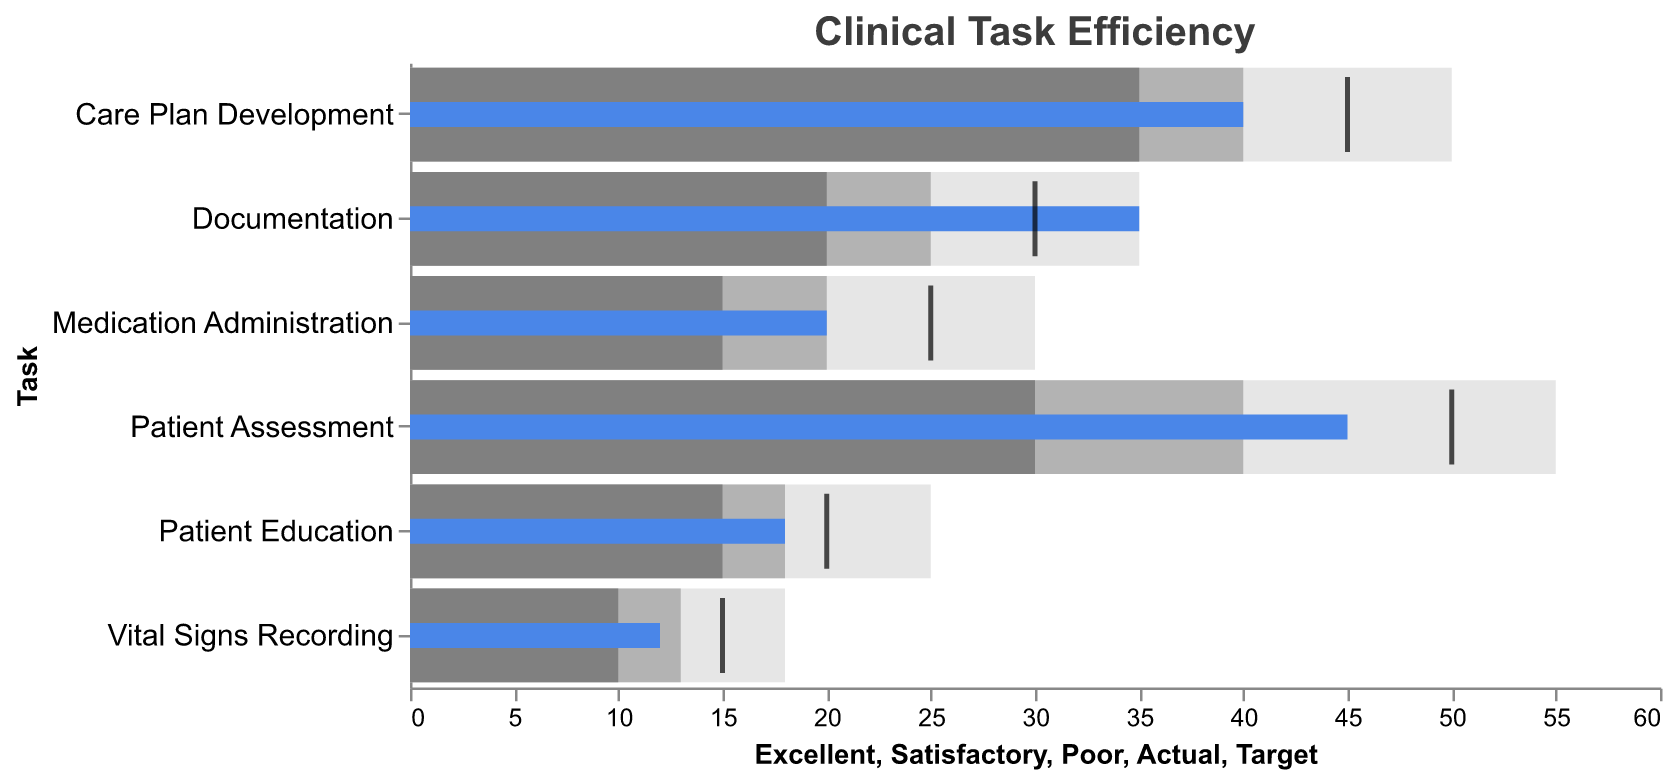What is the title of the chart? The title is displayed prominently at the top of the chart. It reads "Clinical Task Efficiency," indicating that the chart is about how efficiently clinical tasks are managed.
Answer: Clinical Task Efficiency Which task has the poorest actual performance compared to its target? Compare the "Actual" values with the "Target" values for each task and determine which has the largest negative difference.
Answer: Medication Administration What is the actual time spent on Patient Assessment? Look at the blue bar labeled "Actual" for the task "Patient Assessment." The blue bar's length corresponds to the actual time.
Answer: 45 How many tasks have an excellent benchmark of 50 or more? Count the number of tasks where the "Excellent" value is 50 or more. These tasks include Patient Assessment and Care Plan Development.
Answer: 2 Is the time spent on Documentation above the target? Compare the "Actual" value of 35 for Documentation with the "Target" value of 30. Since 35 is greater than 30, it is above the target.
Answer: Yes Which task has the smallest difference between its actual time and target time? Calculate the differences between "Actual" and "Target" for each task and find the smallest one. The difference for Patient Education is 2 (20 - 18).
Answer: Patient Education For Vital Signs Recording, is the actual performance categorized as satisfactory? Compare the "Actual" value of 12 for Vital Signs Recording with the satisfactory range, which is 10 to 13. Since 12 is within this range, it is categorized as satisfactory.
Answer: Yes How much time is spent above the target in Care Plan Development? Subtract the "Target" value from the "Actual" value for Care Plan Development. 40 (Actual) - 45 (Target) = -5, which means it is 5 units below the target.
Answer: 5 units below What is the target time for Patient Education? The target time for Patient Education is marked with a black tick.
Answer: 20 Which task has the best alignment between actual performance and excellent performance? Compare the actual time spent on each task with its excellent benchmark. Determine which actual time is closest to the excellent benchmark.
Answer: Documentation 